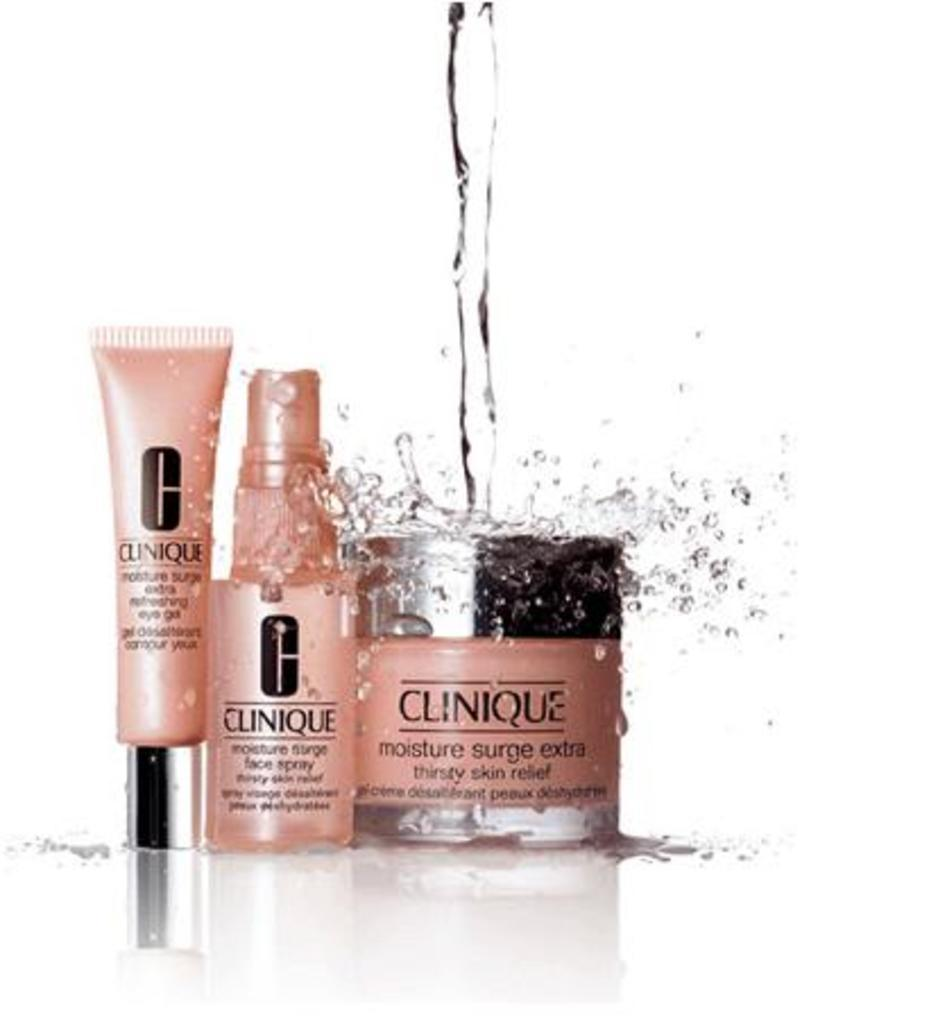What type of items are present in the image? There are cosmetic items in the image. What is happening to the cosmetic items in the image? Water is poured on the cosmetic items. How many fish can be seen swimming in the water poured on the cosmetic items? There are no fish present in the image; it only shows cosmetic items with water being poured on them. 